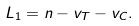<formula> <loc_0><loc_0><loc_500><loc_500>L _ { 1 } = n - v _ { T } - v _ { C } .</formula> 